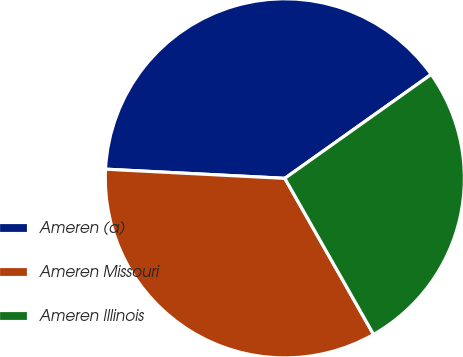<chart> <loc_0><loc_0><loc_500><loc_500><pie_chart><fcel>Ameren (a)<fcel>Ameren Missouri<fcel>Ameren Illinois<nl><fcel>39.36%<fcel>34.04%<fcel>26.6%<nl></chart> 